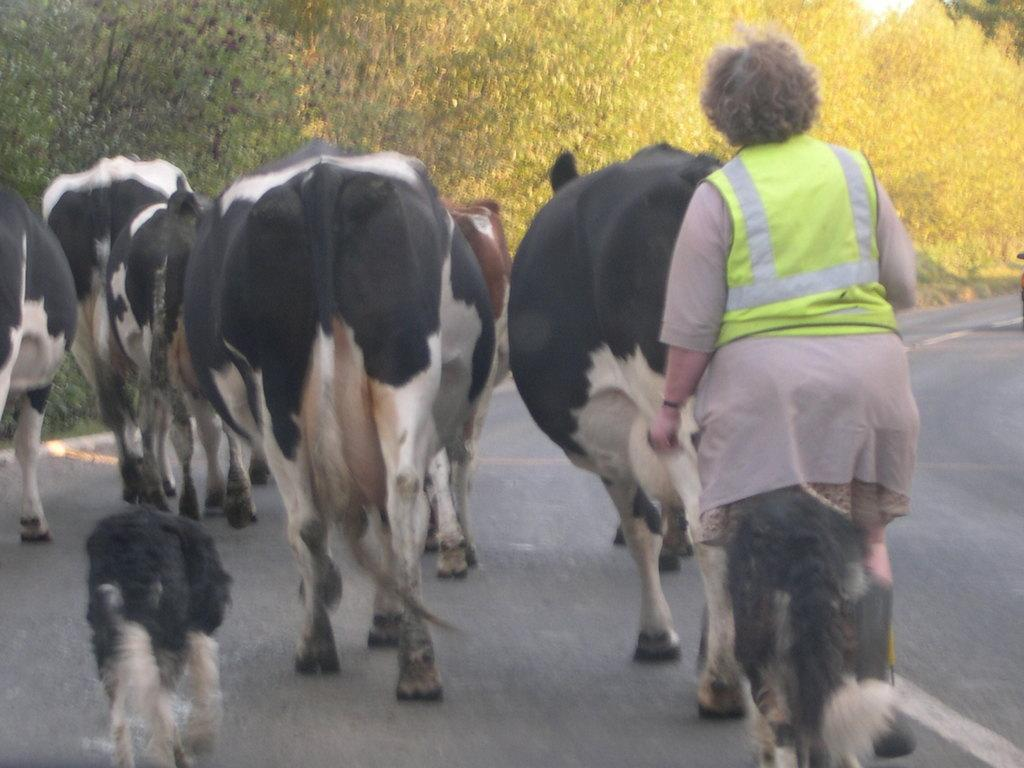What types of living organisms can be seen in the image? There are animals and a person in the image. What is the person doing in the image? The provided facts do not specify what the person is doing. What can be seen under the animals and person in the image? The ground is visible in the image. What type of vegetation is present in the image? There are trees in the image. What type of plant is the person studying for the test in the image? There is no plant or test present in the image. 